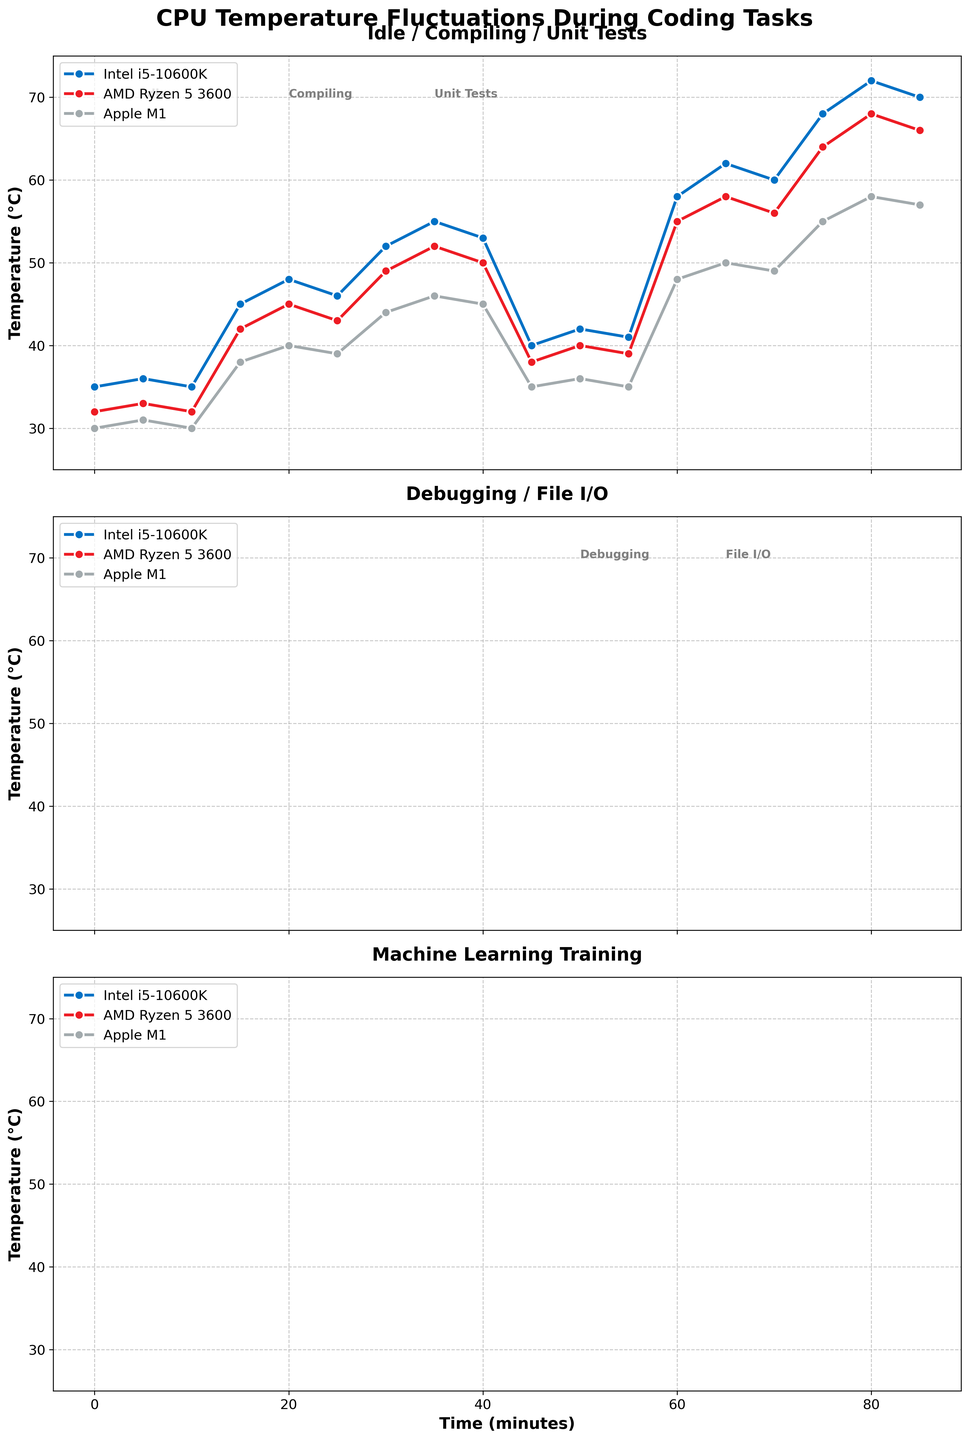What is the title of the figure? The title is located at the top center of the figure and is mentioned in bold.
Answer: CPU Temperature Fluctuations During Coding Tasks What is the color of the line representing the 'Intel i5-10600K' CPU? The line color for the Intel i5-10600K is defined in the plotting function.
Answer: Blue How many subplots are there in the figure? The number of subplots can be determined by counting the individual line charts stacked vertically.
Answer: 3 What is the average temperature of the 'Intel i5-10600K' CPU during running unit tests? To find the average temperature, locate the data points for 'Intel i5-10600K' during unit tests (52, 55, 53), sum them up (52 + 55 + 53 = 160) and then divide by the number of data points (160 / 3).
Answer: 53.3°C Which CPU has the highest temperature during large file I/O operations, and what is its value? By looking at the data points for each CPU during large file I/O operations (Intel: 58, 62, 60; AMD: 55, 58, 56; Apple: 48, 50, 49), find the maximum value.
Answer: Intel i5-10600K at 62°C How does the temperature of the 'Apple M1' CPU change from idle to compiling a small project? Compare the temperatures of Apple M1 at idle (30, 31, 30) and compiling a small project (38, 40, 39). Calculate the differences (38-30, 40-31, 39-30).
Answer: It increases by 8-9°C Which task causes the highest temperature for the 'AMD Ryzen 5 3600' CPU, and what is its value? By examining the maximum points in the subplots for AMD Ryzen 5 3600 CPU, the highest temperature can be identified during machine learning model training, which peaks at 68°C.
Answer: Machine learning model training at 68°C What is the difference in temperature between 'Intel i5-10600K' and 'Apple M1' during debugging with breakpoints? Find the temperatures of Intel i5-10600K and Apple M1 during debugging (Intel: 40, 42, 41; Apple: 35, 36, 35). Calculate differences for each corresponding time point.
Answer: Differences are 5, 6, and 6°C respectively What is the trend of the 'Intel i5-10600K' CPU temperature during machine learning model training? Observing the temperature points for Intel i5-10600K during machine learning training (68, 72, 70), the temperatures increase initially and then slightly drop.
Answer: Increases then slightly drops Which CPU has the lowest initial temperature at idle, and what is that temperature? By comparing the first data points at idle (Intel: 35, AMD: 32, Apple: 30), the lowest initial temperature can be identified.
Answer: Apple M1 at 30°C 